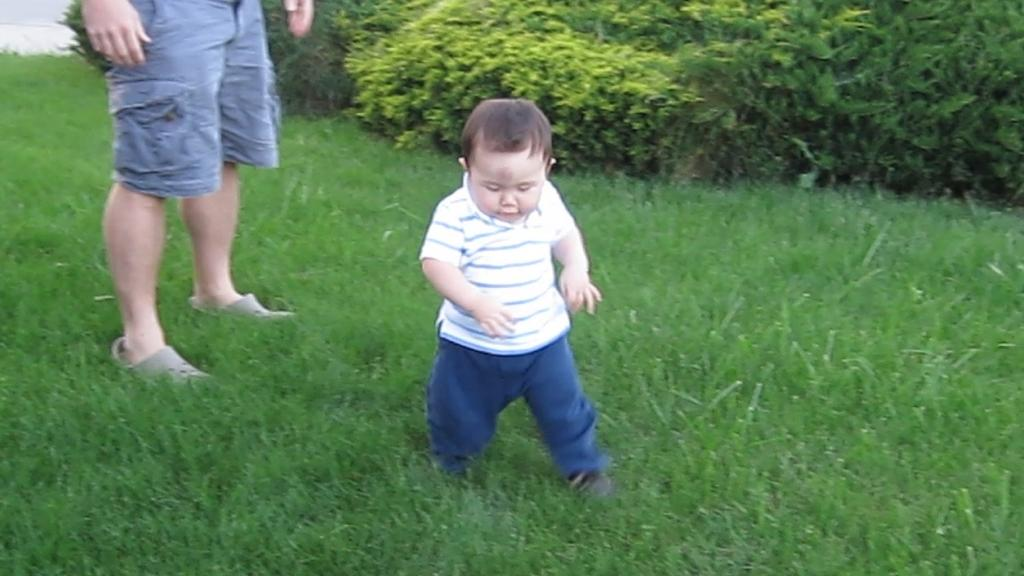How many people can be seen in the image? There are a few people in the image. What is visible beneath the people's feet? The ground is visible in the image. What type of vegetation is present in the image? There is grass and plants in the image. Where is the playground located in the image? There is no playground present in the image. What type of brush can be seen in the image? There is no brush present in the image. 